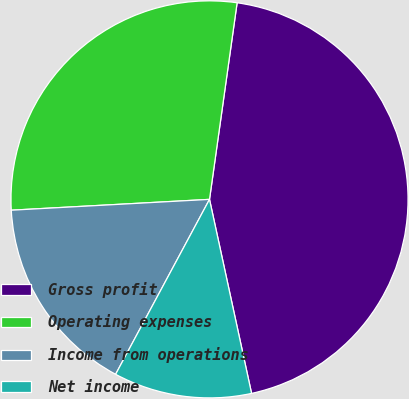<chart> <loc_0><loc_0><loc_500><loc_500><pie_chart><fcel>Gross profit<fcel>Operating expenses<fcel>Income from operations<fcel>Net income<nl><fcel>44.38%<fcel>28.09%<fcel>16.29%<fcel>11.24%<nl></chart> 